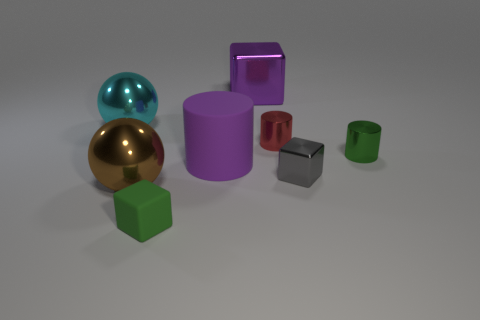Subtract all metal blocks. How many blocks are left? 1 Subtract all red cylinders. How many cylinders are left? 2 Subtract all cylinders. How many objects are left? 5 Add 2 large green matte balls. How many objects exist? 10 Add 7 big rubber things. How many big rubber things are left? 8 Add 2 big yellow shiny things. How many big yellow shiny things exist? 2 Subtract 0 yellow blocks. How many objects are left? 8 Subtract 1 spheres. How many spheres are left? 1 Subtract all yellow cylinders. Subtract all green balls. How many cylinders are left? 3 Subtract all brown blocks. How many green cylinders are left? 1 